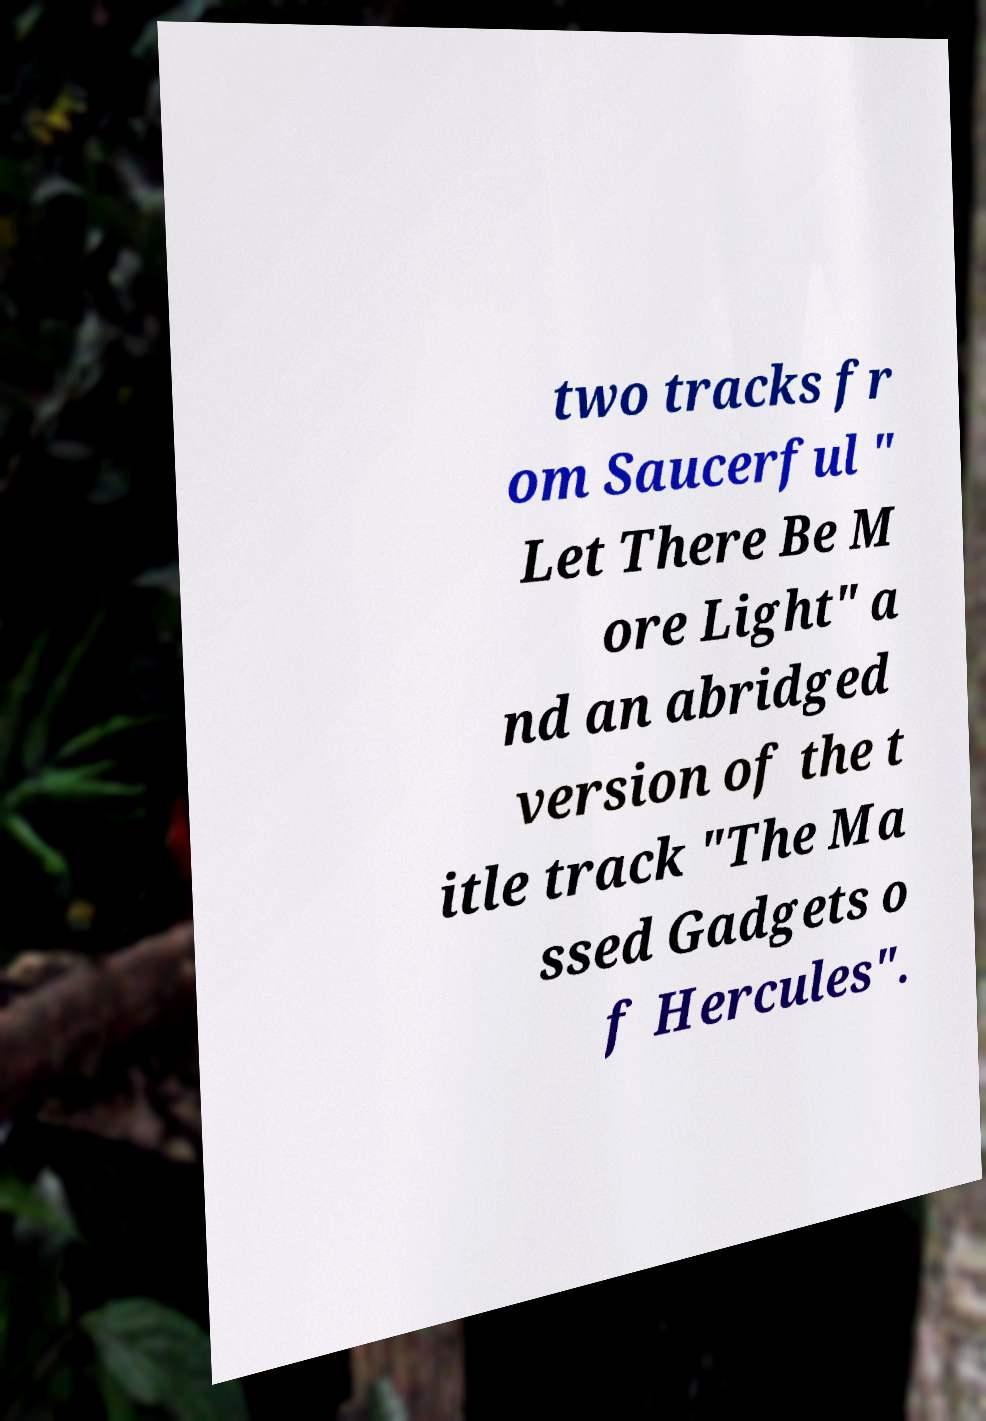For documentation purposes, I need the text within this image transcribed. Could you provide that? two tracks fr om Saucerful " Let There Be M ore Light" a nd an abridged version of the t itle track "The Ma ssed Gadgets o f Hercules". 